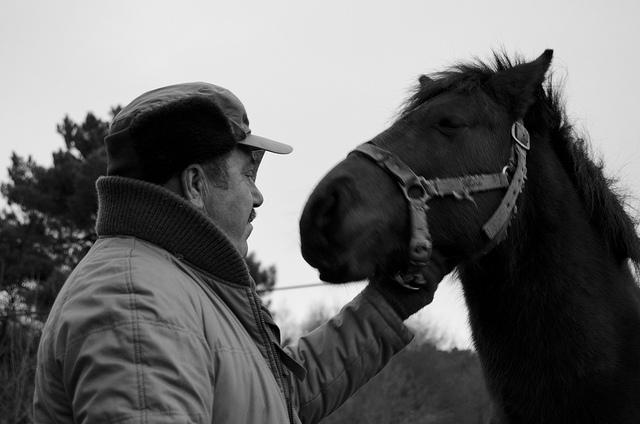Can this animal get hurt if he walks forward?
Short answer required. No. Does the man love horses?
Give a very brief answer. Yes. What is he petting?
Short answer required. Horse. What style hat does the man wear?
Short answer required. Cap. 